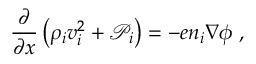Convert formula to latex. <formula><loc_0><loc_0><loc_500><loc_500>\frac { \partial } { \partial x } \left ( \rho _ { i } v _ { i } ^ { 2 } + \mathcal { P } _ { i } \right ) = - e n _ { i } \nabla \phi \, ,</formula> 